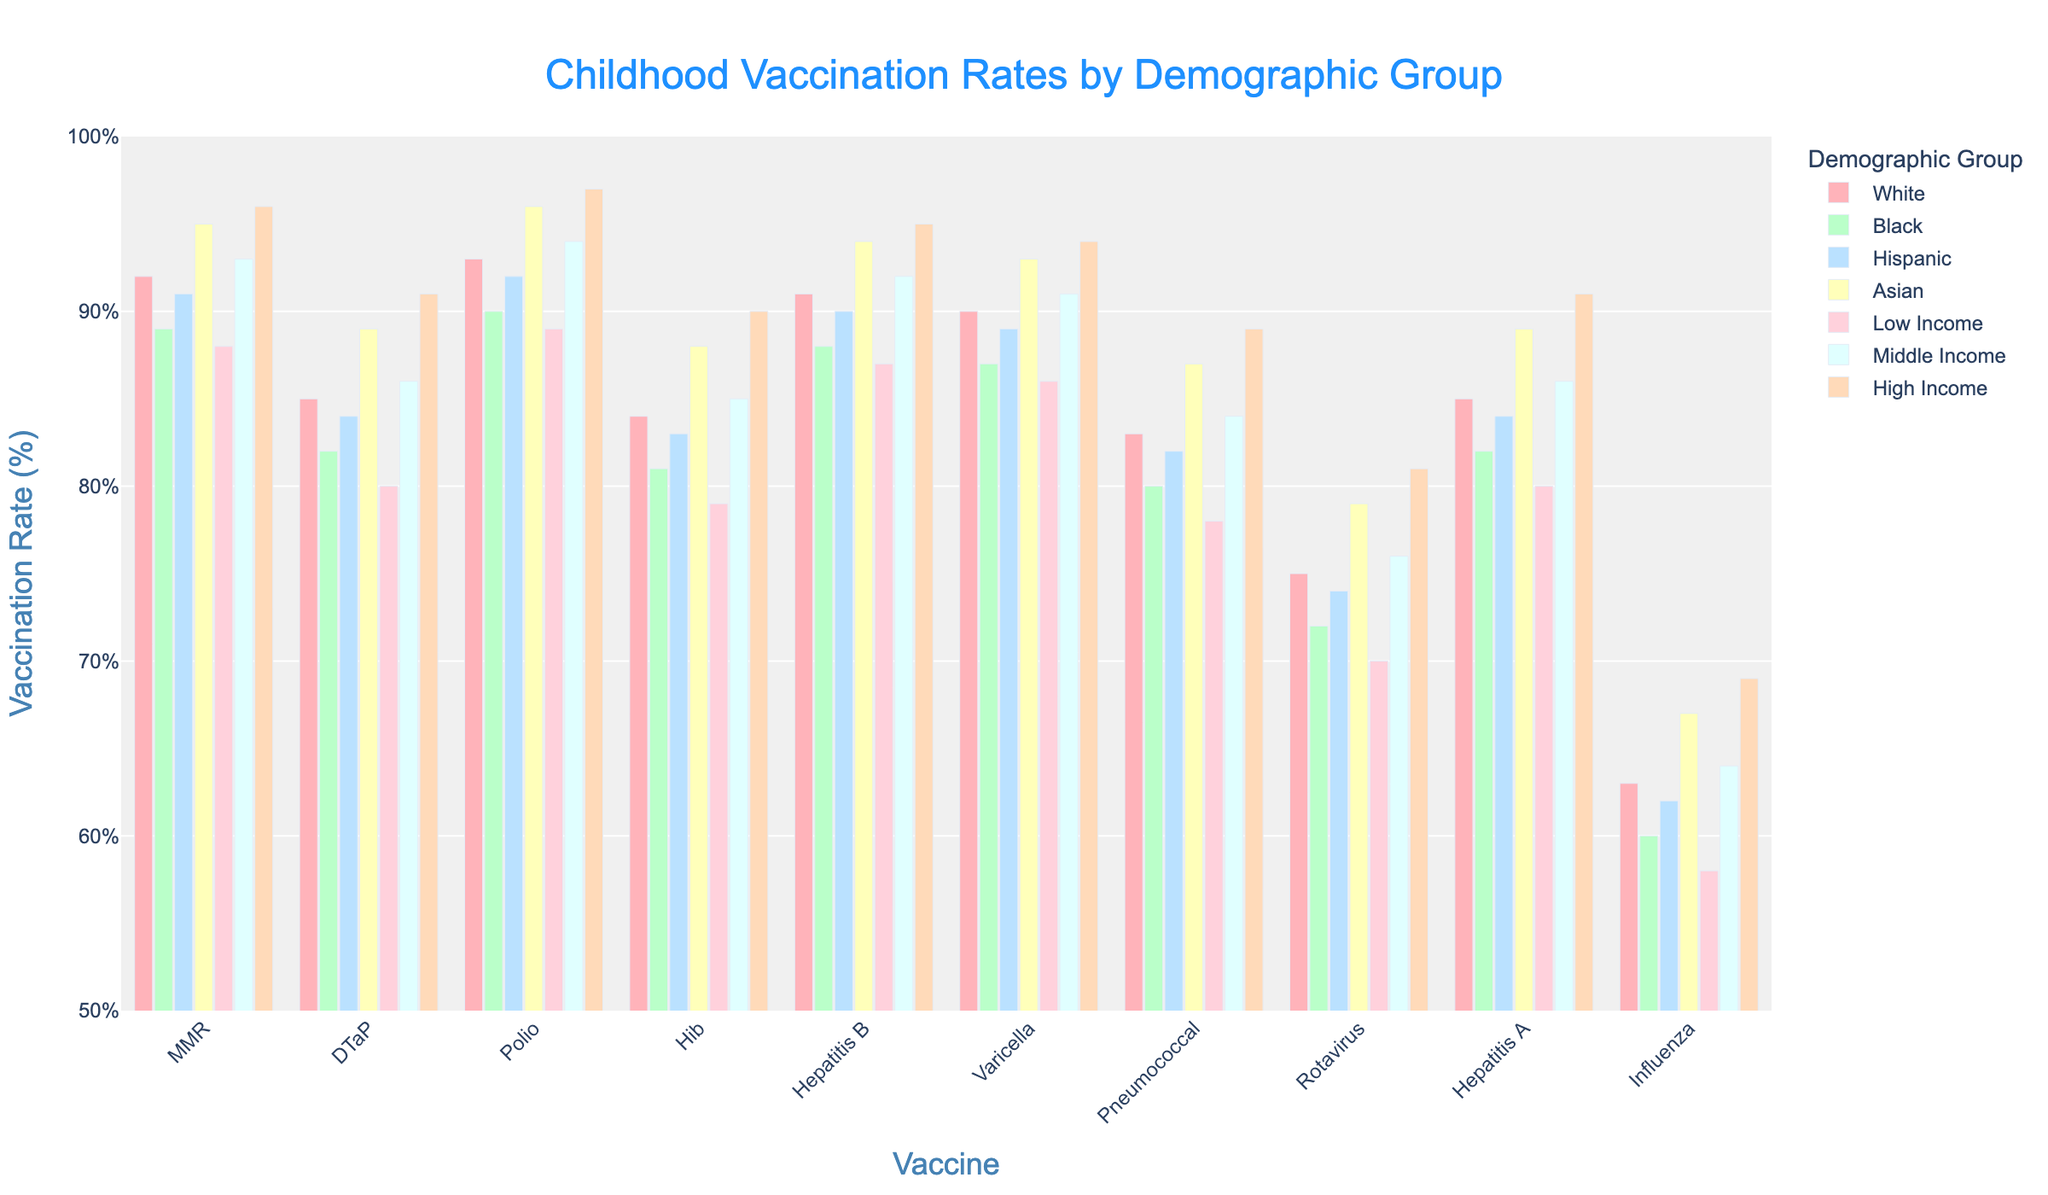What is the highest vaccination rate among all vaccines and demographic groups? Look at the chart and find the tallest bar. The vaccine with the highest rate is Polio, vaccinated in the High-Income group at a rate of 97%.
Answer: 97% Which vaccine has the lowest vaccination rate among all demographic groups? Observe the shortest bar in the chart. The vaccine with the lowest rate is Influenza, vaccinated in Low-Income group at a rate of 58%.
Answer: 58% How does the vaccination rate for MMR compare between the Asian and Hispanic groups? Find the bars for MMR under the Asian and Hispanic groups. The rate for Asian is 95% and for Hispanic is 91%, so Asian is higher.
Answer: Asian is higher What's the difference in vaccination rates for DTaP between Middle Income and Low Income groups? Locate the bars for DTaP under Middle Income and Low Income groups. The rates are 86% for Middle Income and 80% for Low Income, so the difference is 86 - 80 = 6%.
Answer: 6% Among the listed demographic groups, which has the highest overall vaccination rate for Hepatitis B? Check the bars for Hepatitis B across all demographic groups and find the tallest bar. The highest rate is in the High-Income group at 95%.
Answer: High-Income group What is the average vaccination rate for Rotavirus across all income groups? Add the vaccination rates for Low Income (70%), Middle Income (76%), and High Income (81%) and then divide by 3. The calculation is (70 + 76 + 81) / 3 = 75.67%.
Answer: 75.67% Is the vaccination rate for Polio higher among High-Income groups or Asian groups? Compare the bars for Polio under High-Income and Asian groups. The rate for High-Income is 97% and for Asian is 96%, so High-Income is higher.
Answer: High-Income is higher What is the median vaccination rate for Varicella among all ethnic groups? First, list the Varicella rates for all ethnic groups: White (90%), Black (87%), Hispanic (89%), and Asian (93%). Order them: 87, 89, 90, 93. The median is the average of the two middle numbers: (89 + 90) / 2 = 89.5%.
Answer: 89.5% Which has the highest overall vaccination rate for Hib, between High-Income and White groups? Compare the Hib vaccination rates for High-Income (90%) and White groups (84%). The High-Income group has the higher rate at 90%.
Answer: High-Income How much higher is the vaccination rate for Pneumococcal in the High-Income group compared to the Low-Income group? Look at the Pneumococcal rates for High-Income (89%) and Low-Income (78%). The difference is 89 - 78 = 11%.
Answer: 11% 